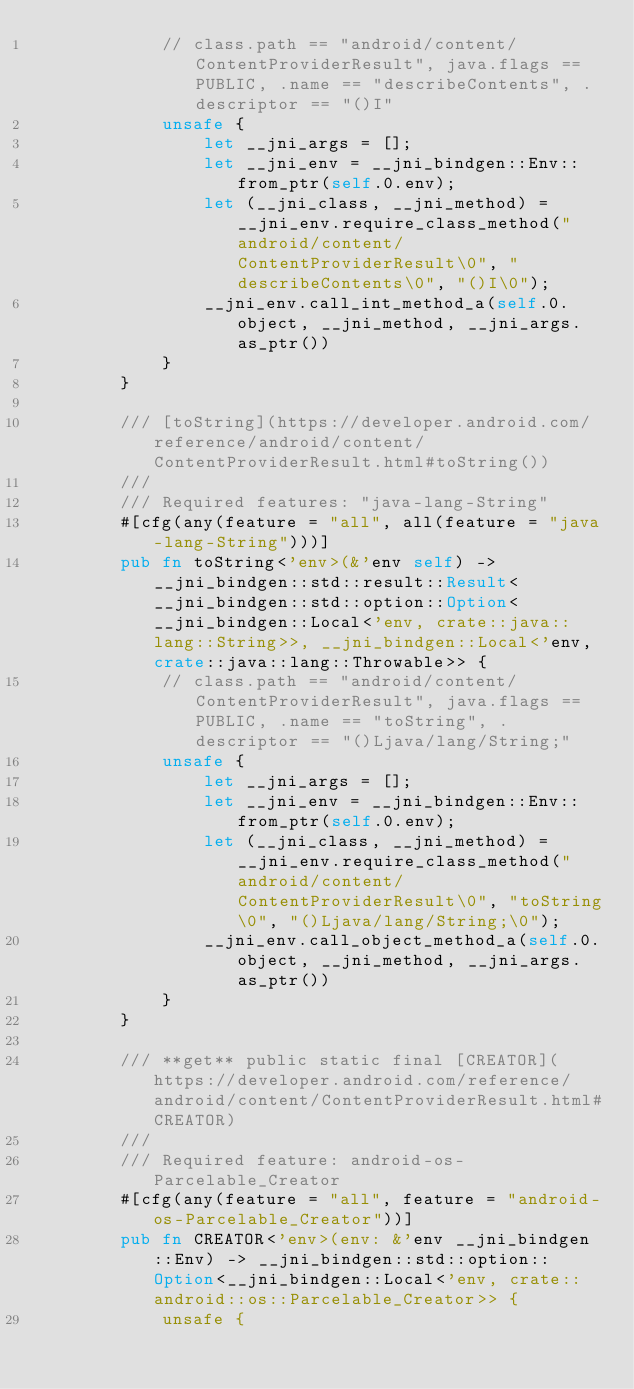<code> <loc_0><loc_0><loc_500><loc_500><_Rust_>            // class.path == "android/content/ContentProviderResult", java.flags == PUBLIC, .name == "describeContents", .descriptor == "()I"
            unsafe {
                let __jni_args = [];
                let __jni_env = __jni_bindgen::Env::from_ptr(self.0.env);
                let (__jni_class, __jni_method) = __jni_env.require_class_method("android/content/ContentProviderResult\0", "describeContents\0", "()I\0");
                __jni_env.call_int_method_a(self.0.object, __jni_method, __jni_args.as_ptr())
            }
        }

        /// [toString](https://developer.android.com/reference/android/content/ContentProviderResult.html#toString())
        ///
        /// Required features: "java-lang-String"
        #[cfg(any(feature = "all", all(feature = "java-lang-String")))]
        pub fn toString<'env>(&'env self) -> __jni_bindgen::std::result::Result<__jni_bindgen::std::option::Option<__jni_bindgen::Local<'env, crate::java::lang::String>>, __jni_bindgen::Local<'env, crate::java::lang::Throwable>> {
            // class.path == "android/content/ContentProviderResult", java.flags == PUBLIC, .name == "toString", .descriptor == "()Ljava/lang/String;"
            unsafe {
                let __jni_args = [];
                let __jni_env = __jni_bindgen::Env::from_ptr(self.0.env);
                let (__jni_class, __jni_method) = __jni_env.require_class_method("android/content/ContentProviderResult\0", "toString\0", "()Ljava/lang/String;\0");
                __jni_env.call_object_method_a(self.0.object, __jni_method, __jni_args.as_ptr())
            }
        }

        /// **get** public static final [CREATOR](https://developer.android.com/reference/android/content/ContentProviderResult.html#CREATOR)
        ///
        /// Required feature: android-os-Parcelable_Creator
        #[cfg(any(feature = "all", feature = "android-os-Parcelable_Creator"))]
        pub fn CREATOR<'env>(env: &'env __jni_bindgen::Env) -> __jni_bindgen::std::option::Option<__jni_bindgen::Local<'env, crate::android::os::Parcelable_Creator>> {
            unsafe {</code> 